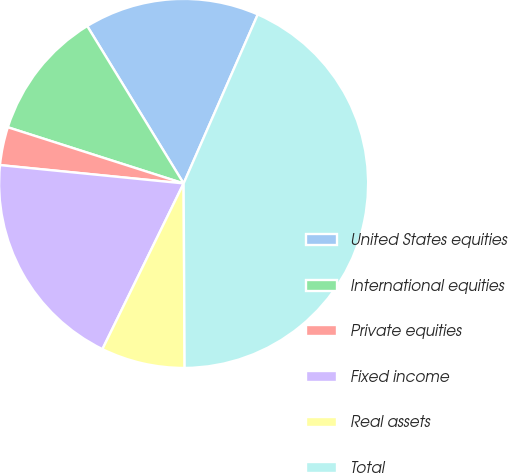Convert chart to OTSL. <chart><loc_0><loc_0><loc_500><loc_500><pie_chart><fcel>United States equities<fcel>International equities<fcel>Private equities<fcel>Fixed income<fcel>Real assets<fcel>Total<nl><fcel>15.33%<fcel>11.33%<fcel>3.34%<fcel>19.33%<fcel>7.34%<fcel>43.33%<nl></chart> 